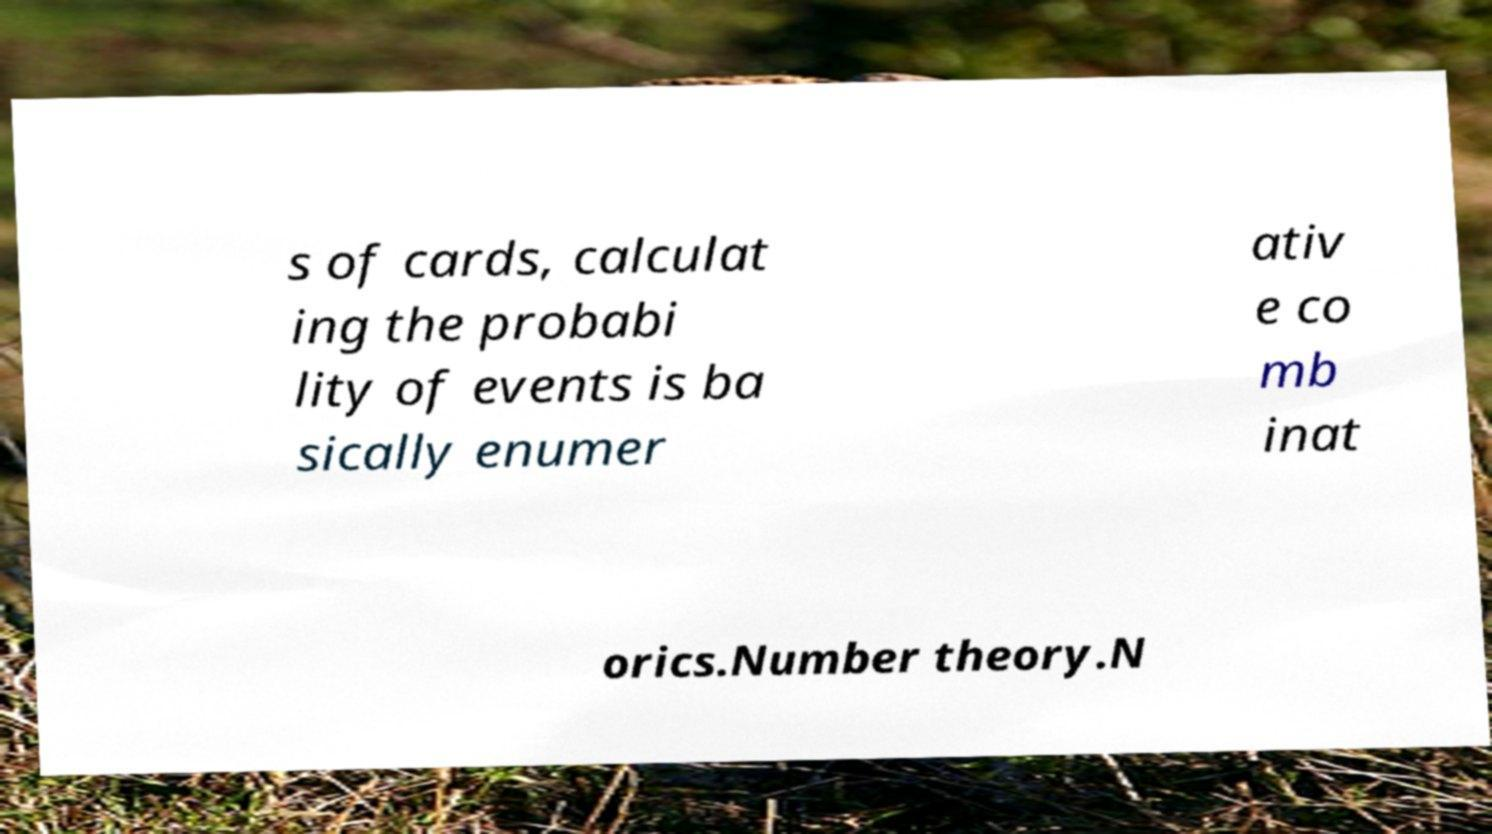Please read and relay the text visible in this image. What does it say? s of cards, calculat ing the probabi lity of events is ba sically enumer ativ e co mb inat orics.Number theory.N 